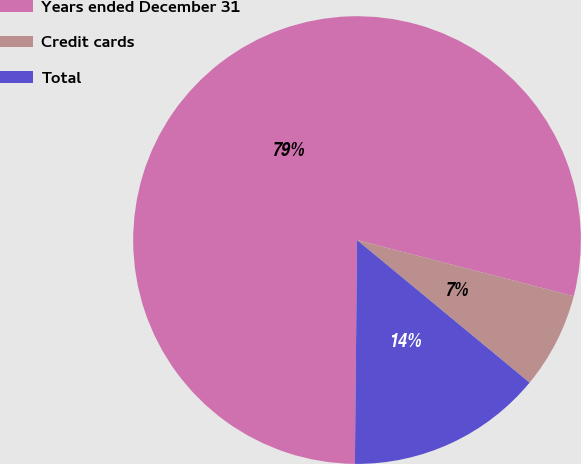Convert chart. <chart><loc_0><loc_0><loc_500><loc_500><pie_chart><fcel>Years ended December 31<fcel>Credit cards<fcel>Total<nl><fcel>78.88%<fcel>6.96%<fcel>14.16%<nl></chart> 